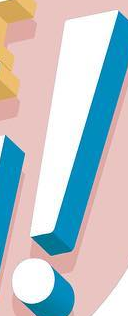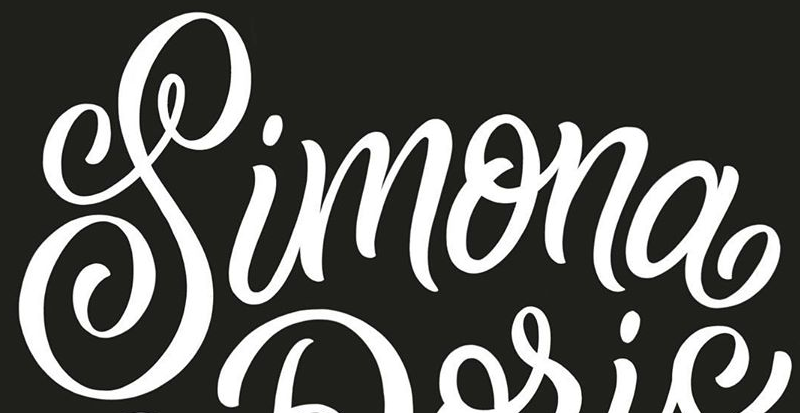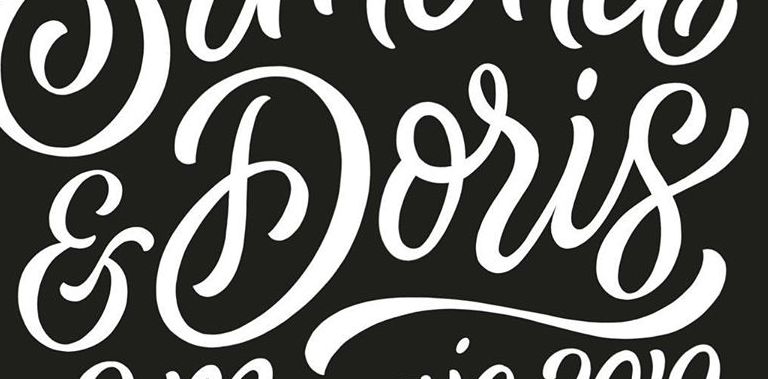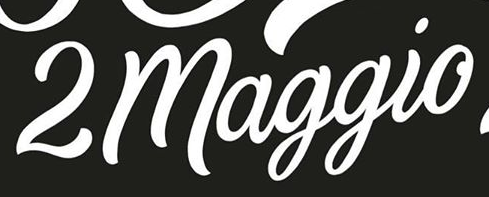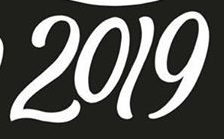What text is displayed in these images sequentially, separated by a semicolon? !; Simona; &Doris; 2maggio; 2019 